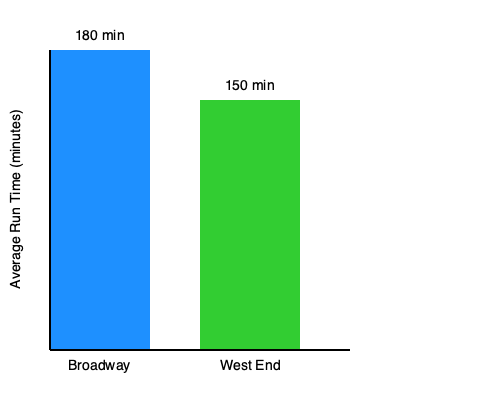Based on the bar chart comparing average run times of Broadway and West End productions, what is the difference in minutes between the two, and which has the longer average run time? To answer this question, we need to follow these steps:

1. Identify the average run times:
   - Broadway: 180 minutes
   - West End: 150 minutes

2. Calculate the difference:
   $180 - 150 = 30$ minutes

3. Determine which has the longer average run time:
   Since 180 > 150, Broadway has the longer average run time.

Therefore, the difference in average run time between Broadway and West End productions is 30 minutes, with Broadway having the longer average run time.
Answer: 30 minutes; Broadway 